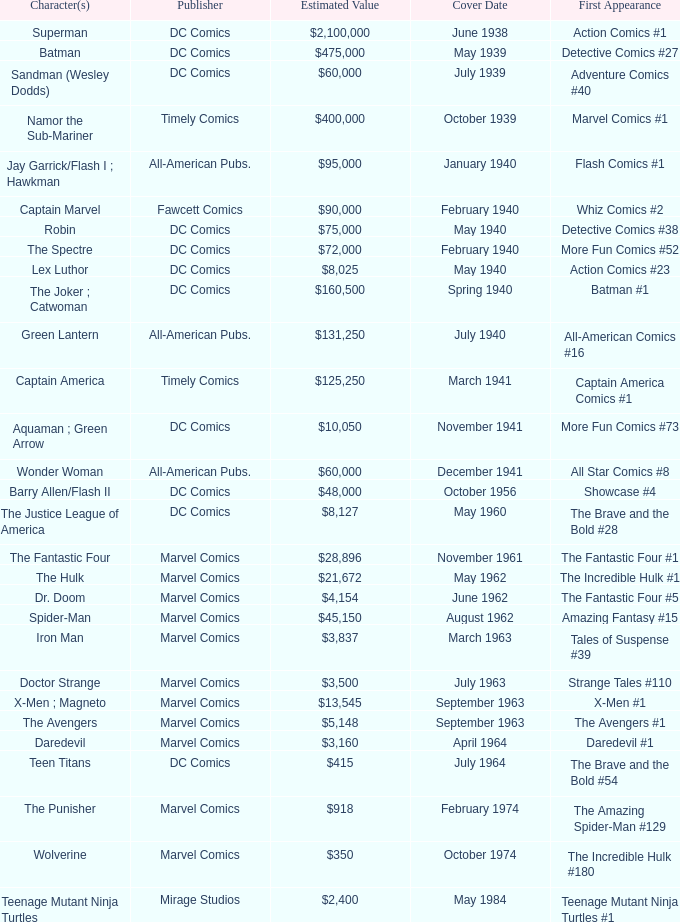What is Action Comics #1's estimated value? $2,100,000. 